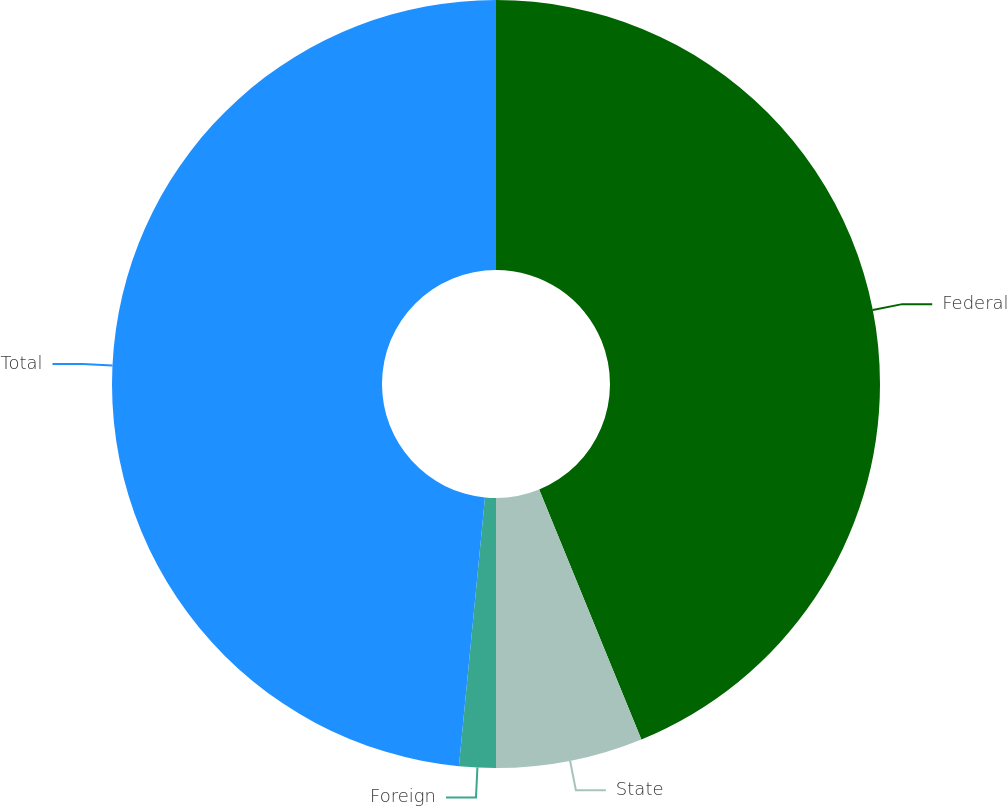<chart> <loc_0><loc_0><loc_500><loc_500><pie_chart><fcel>Federal<fcel>State<fcel>Foreign<fcel>Total<nl><fcel>43.82%<fcel>6.18%<fcel>1.54%<fcel>48.46%<nl></chart> 